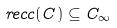<formula> <loc_0><loc_0><loc_500><loc_500>r e c c ( C ) \subseteq C _ { \infty }</formula> 